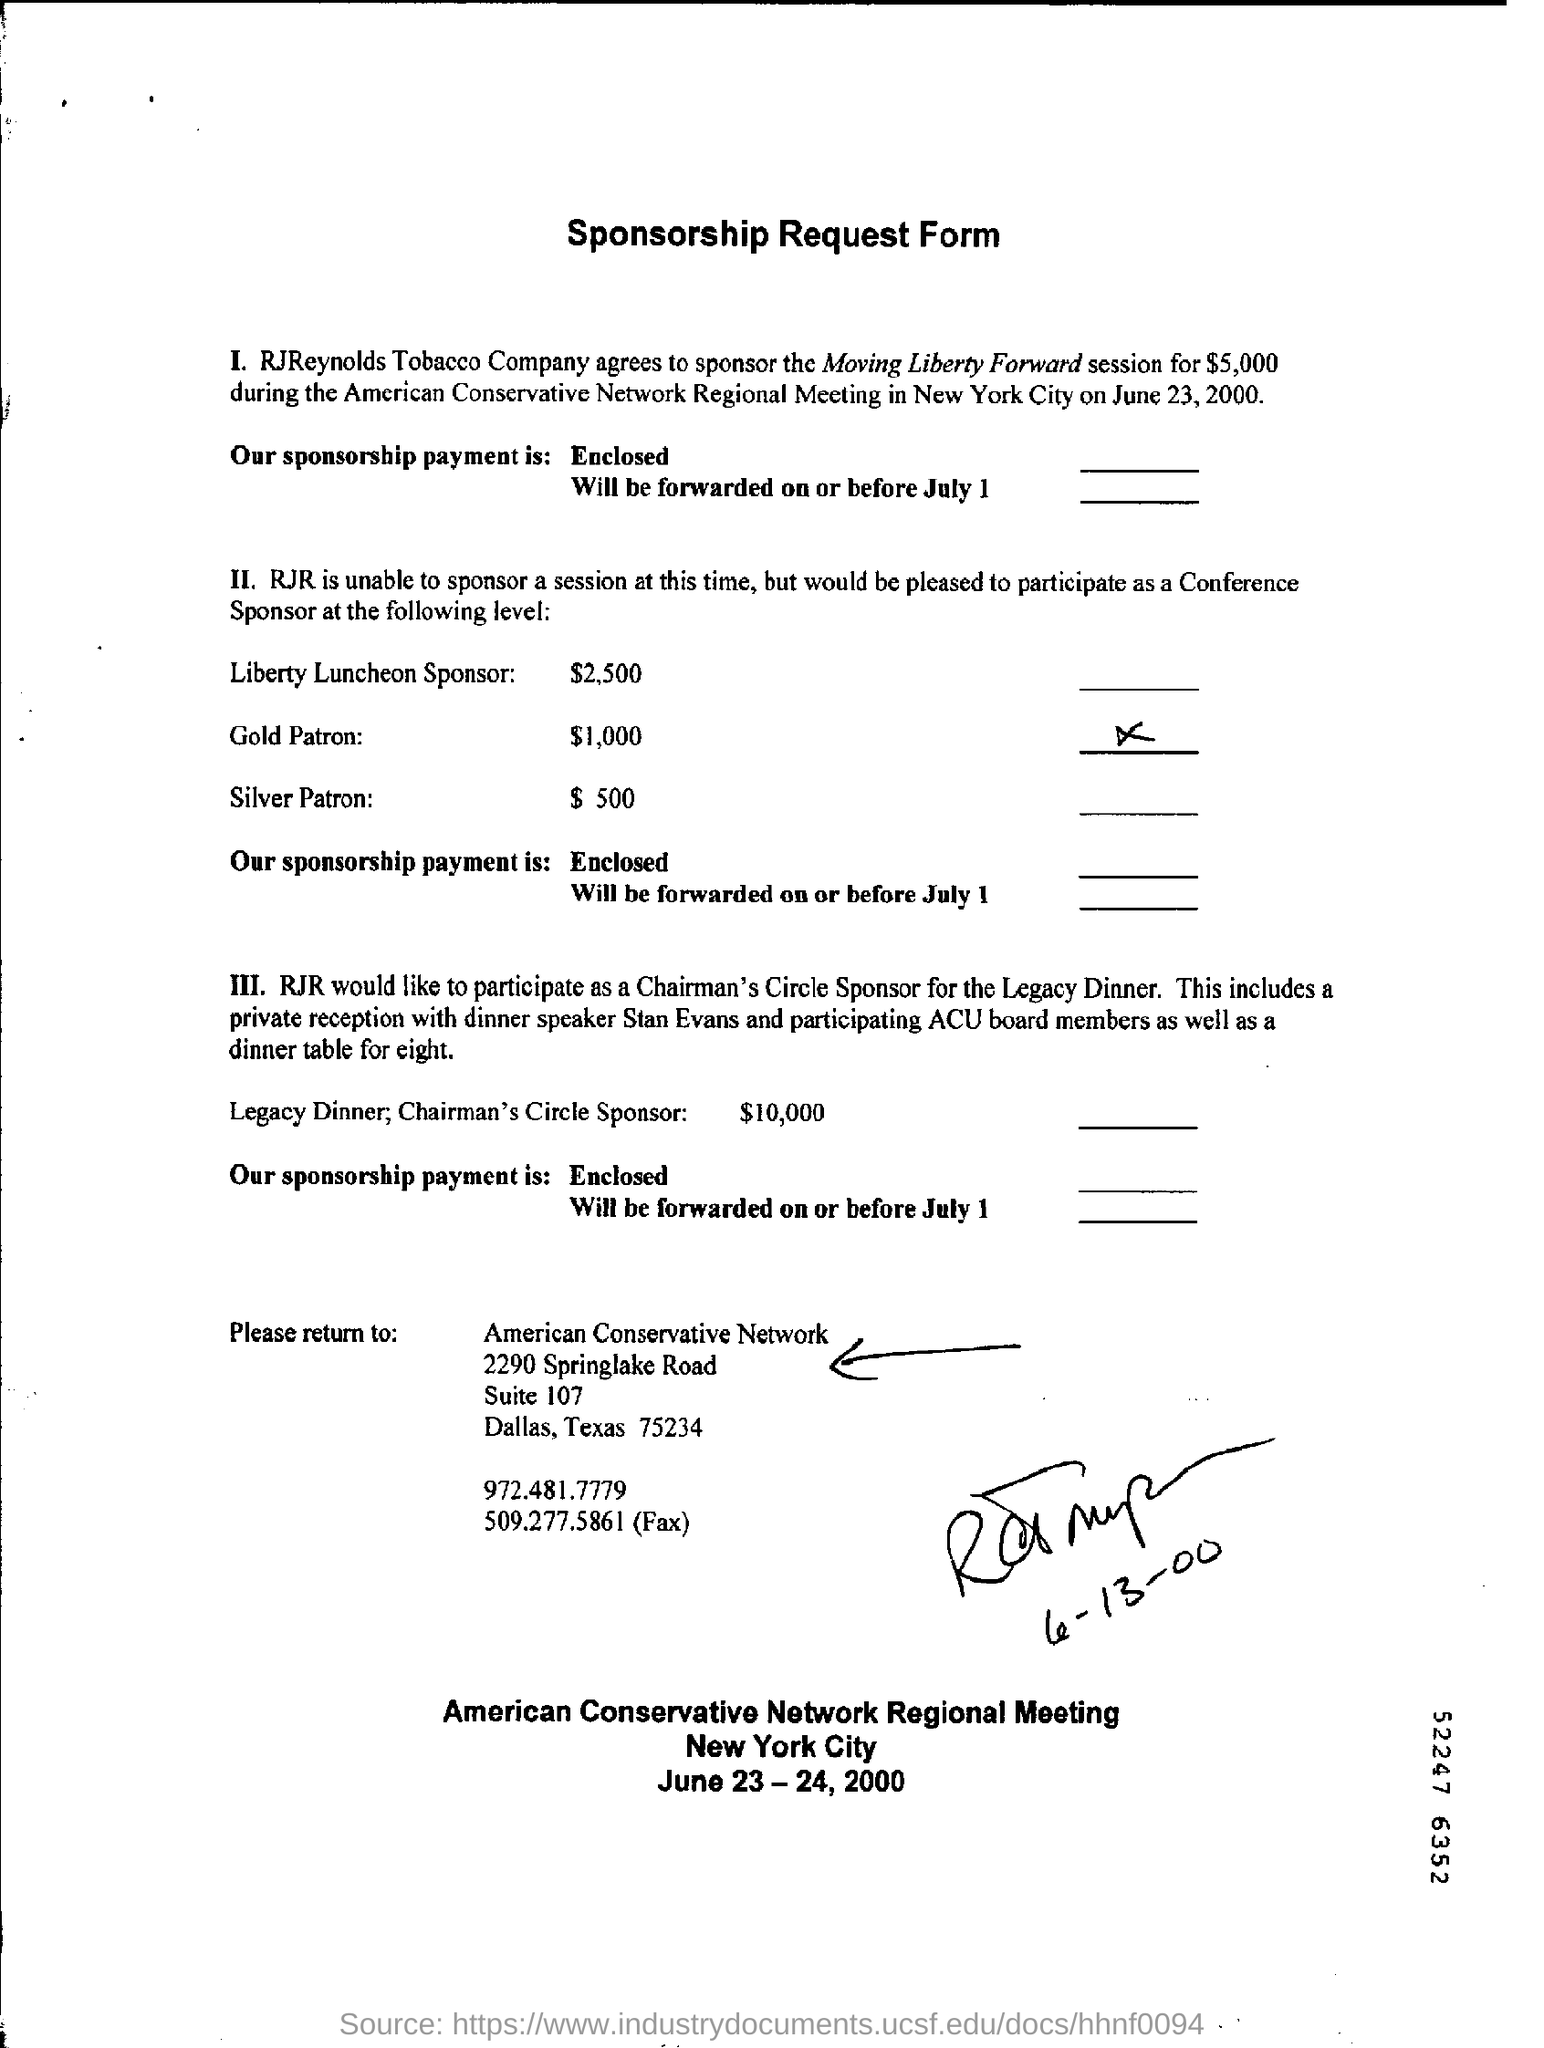Who agreed to sponsor the Moving Liberty Forward session?
Provide a succinct answer. RJReynolds Tobacco Company. How much did RJReynolds Tobacco Company agreed to sponsor the Moving Liberty Forward session for?
Your answer should be very brief. $5,000. When is the American Conservative Network Regional Meeting held?
Provide a succinct answer. On june 23, 2000. Where is American Conservative Regional Meeting held?
Provide a succinct answer. New york city. What is the Fax Number for American Conservative Network?
Your answer should be compact. 509.277.5861. 